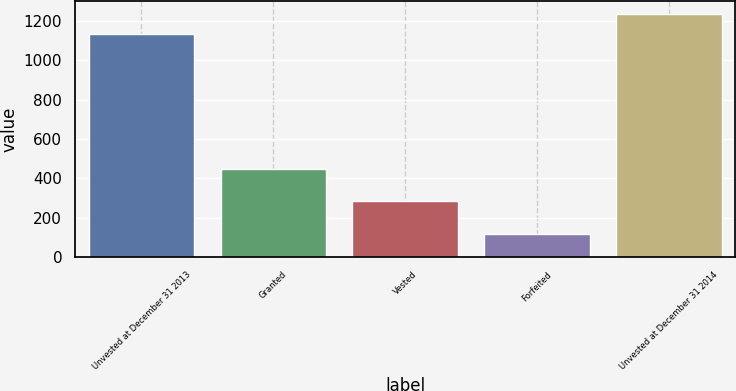<chart> <loc_0><loc_0><loc_500><loc_500><bar_chart><fcel>Unvested at December 31 2013<fcel>Granted<fcel>Vested<fcel>Forfeited<fcel>Unvested at December 31 2014<nl><fcel>1131<fcel>447<fcel>282<fcel>119<fcel>1236.8<nl></chart> 